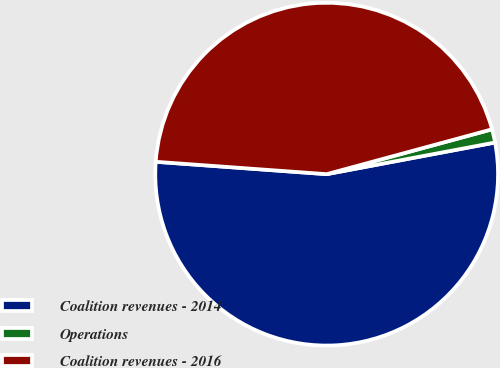Convert chart to OTSL. <chart><loc_0><loc_0><loc_500><loc_500><pie_chart><fcel>Coalition revenues - 2014<fcel>Operations<fcel>Coalition revenues - 2016<nl><fcel>54.11%<fcel>1.26%<fcel>44.63%<nl></chart> 